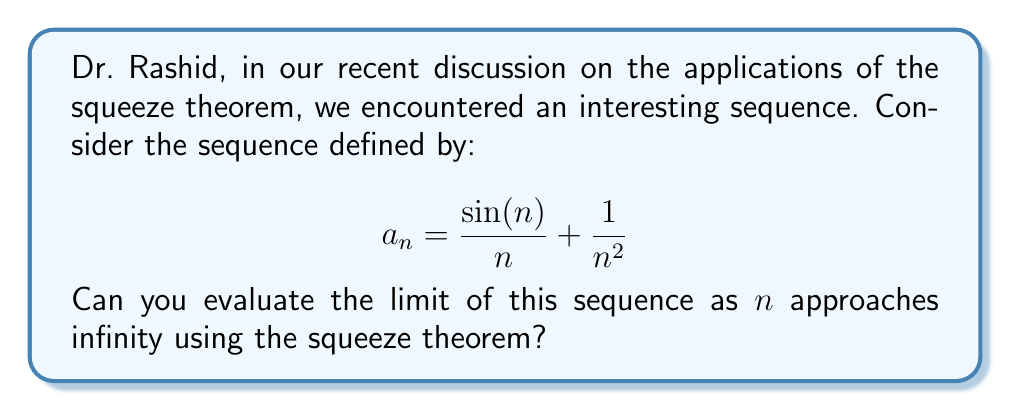Solve this math problem. To evaluate this limit using the squeeze theorem, we need to find two sequences that "squeeze" our given sequence and have the same limit. Let's approach this step-by-step:

1) First, let's consider the bounds of $\sin(n)$:
   $$-1 \leq \sin(n) \leq 1$$

2) Dividing all parts by $n$ (which is positive for large $n$):
   $$-\frac{1}{n} \leq \frac{\sin(n)}{n} \leq \frac{1}{n}$$

3) Adding $\frac{1}{n^2}$ to all parts:
   $$-\frac{1}{n} + \frac{1}{n^2} \leq \frac{\sin(n)}{n} + \frac{1}{n^2} \leq \frac{1}{n} + \frac{1}{n^2}$$

4) Now we have our squeeze:
   $$-\frac{1}{n} + \frac{1}{n^2} \leq a_n \leq \frac{1}{n} + \frac{1}{n^2}$$

5) Let's evaluate the limits of the left and right sides:
   
   $$\lim_{n \to \infty} (-\frac{1}{n} + \frac{1}{n^2}) = 0$$
   $$\lim_{n \to \infty} (\frac{1}{n} + \frac{1}{n^2}) = 0$$

6) Since both the lower and upper bounds converge to 0, by the squeeze theorem, we can conclude:

   $$\lim_{n \to \infty} a_n = 0$$

Thus, the sequence converges to 0 as $n$ approaches infinity.
Answer: $0$ 